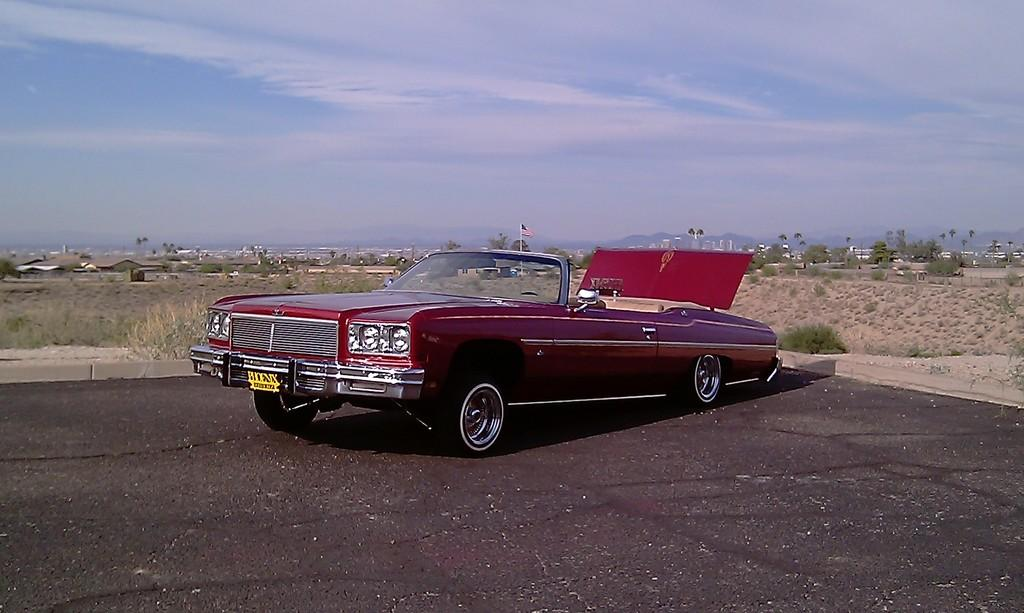What is the main subject of the image? There is a vehicle in the image. What else can be seen in the image besides the vehicle? There are poles, a flag, a road, ground, plants, trees, buildings, mountains, and the sky visible in the image. Can you describe the sky in the image? The sky is visible in the image, and there are clouds present. What type of terrain is visible in the image? The image shows a combination of ground, trees, and mountains. What is the tax rate for the railway in the image? There is no railway present in the image, and therefore no tax rate can be determined. 